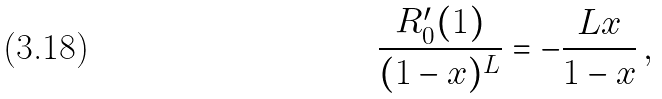<formula> <loc_0><loc_0><loc_500><loc_500>\frac { R _ { 0 } ^ { \prime } ( 1 ) } { ( 1 - x ) ^ { L } } = - \frac { L x } { 1 - x } \, ,</formula> 